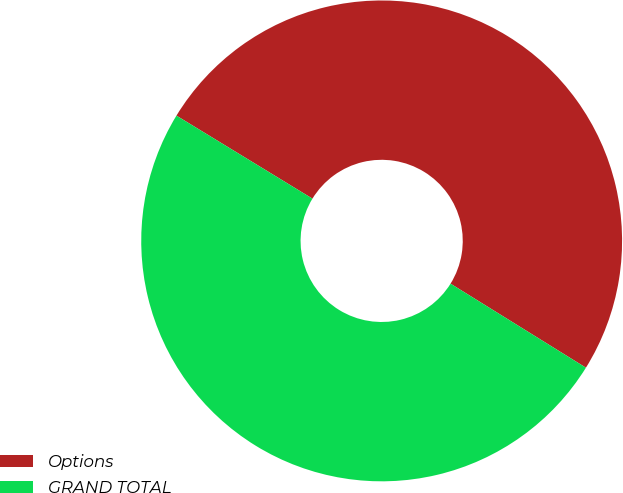Convert chart. <chart><loc_0><loc_0><loc_500><loc_500><pie_chart><fcel>Options<fcel>GRAND TOTAL<nl><fcel>50.12%<fcel>49.88%<nl></chart> 